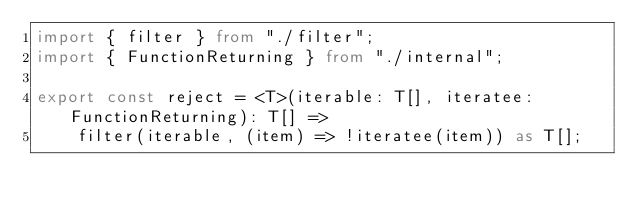<code> <loc_0><loc_0><loc_500><loc_500><_TypeScript_>import { filter } from "./filter";
import { FunctionReturning } from "./internal";

export const reject = <T>(iterable: T[], iteratee: FunctionReturning): T[] =>
    filter(iterable, (item) => !iteratee(item)) as T[];
</code> 